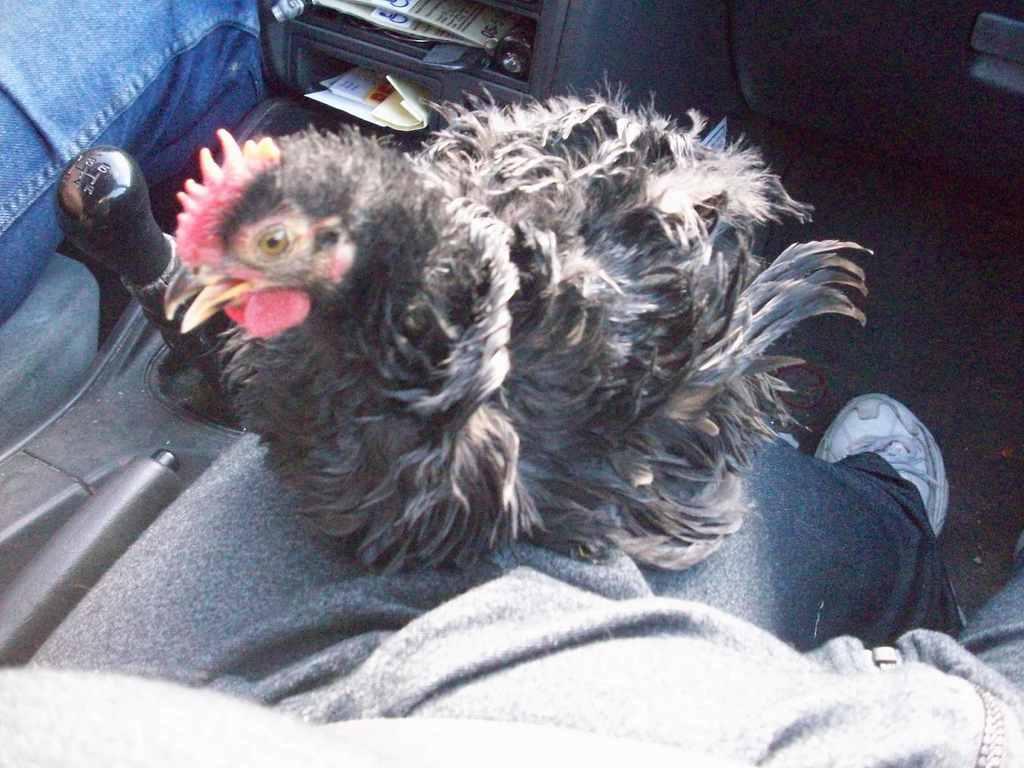How would you summarize this image in a sentence or two? In this image I can see two people and a bird in the vehicle. I can see the gear rod and few papers. 